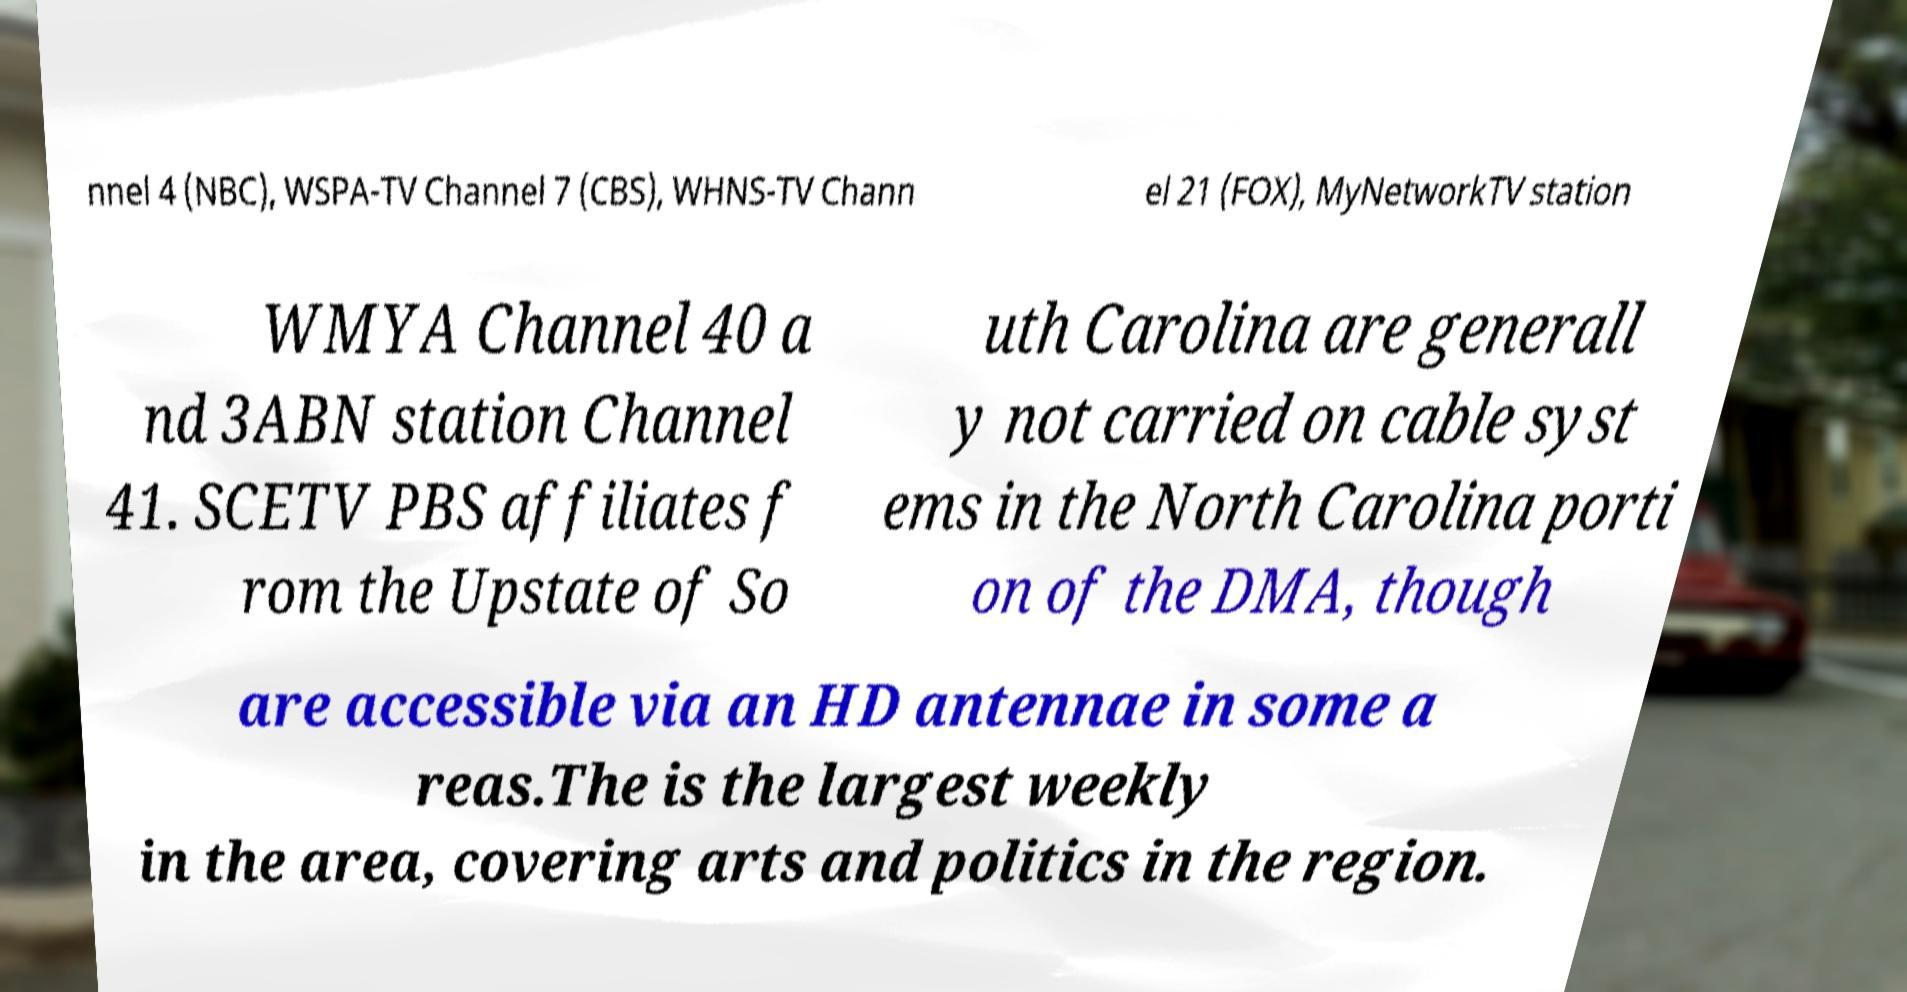Could you assist in decoding the text presented in this image and type it out clearly? nnel 4 (NBC), WSPA-TV Channel 7 (CBS), WHNS-TV Chann el 21 (FOX), MyNetworkTV station WMYA Channel 40 a nd 3ABN station Channel 41. SCETV PBS affiliates f rom the Upstate of So uth Carolina are generall y not carried on cable syst ems in the North Carolina porti on of the DMA, though are accessible via an HD antennae in some a reas.The is the largest weekly in the area, covering arts and politics in the region. 